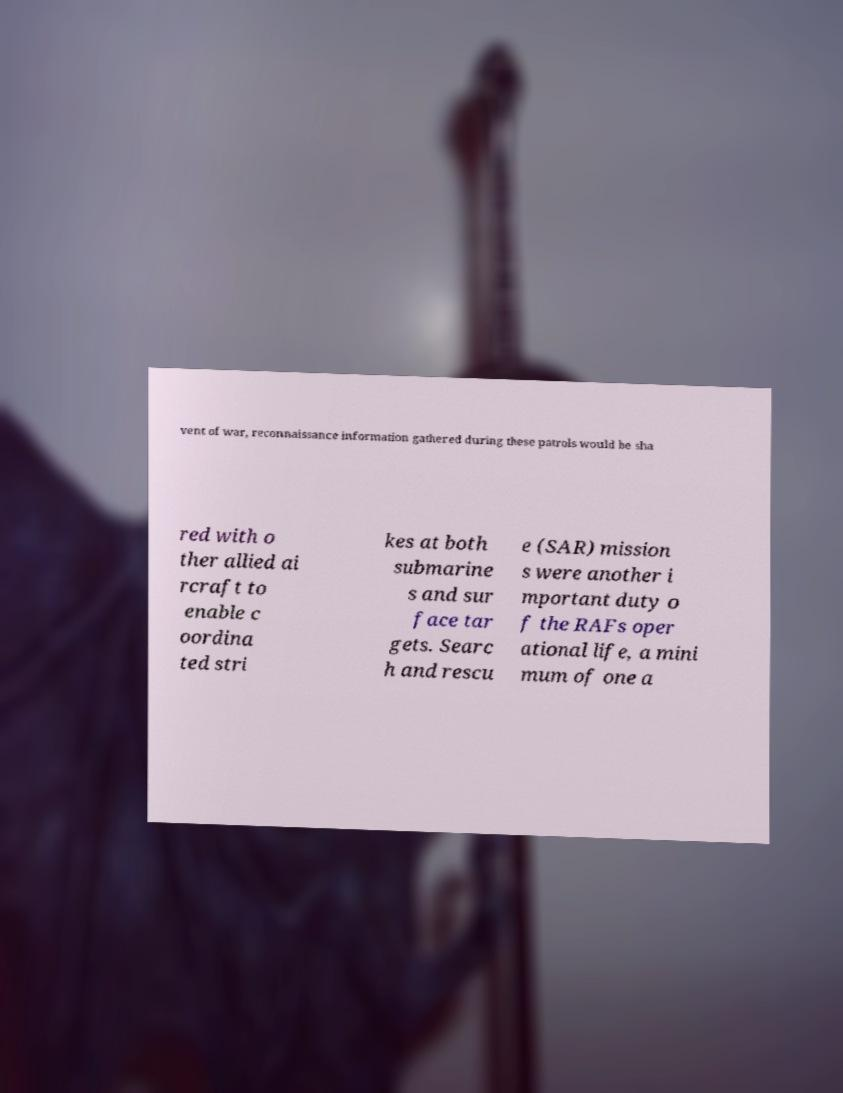I need the written content from this picture converted into text. Can you do that? vent of war, reconnaissance information gathered during these patrols would be sha red with o ther allied ai rcraft to enable c oordina ted stri kes at both submarine s and sur face tar gets. Searc h and rescu e (SAR) mission s were another i mportant duty o f the RAFs oper ational life, a mini mum of one a 